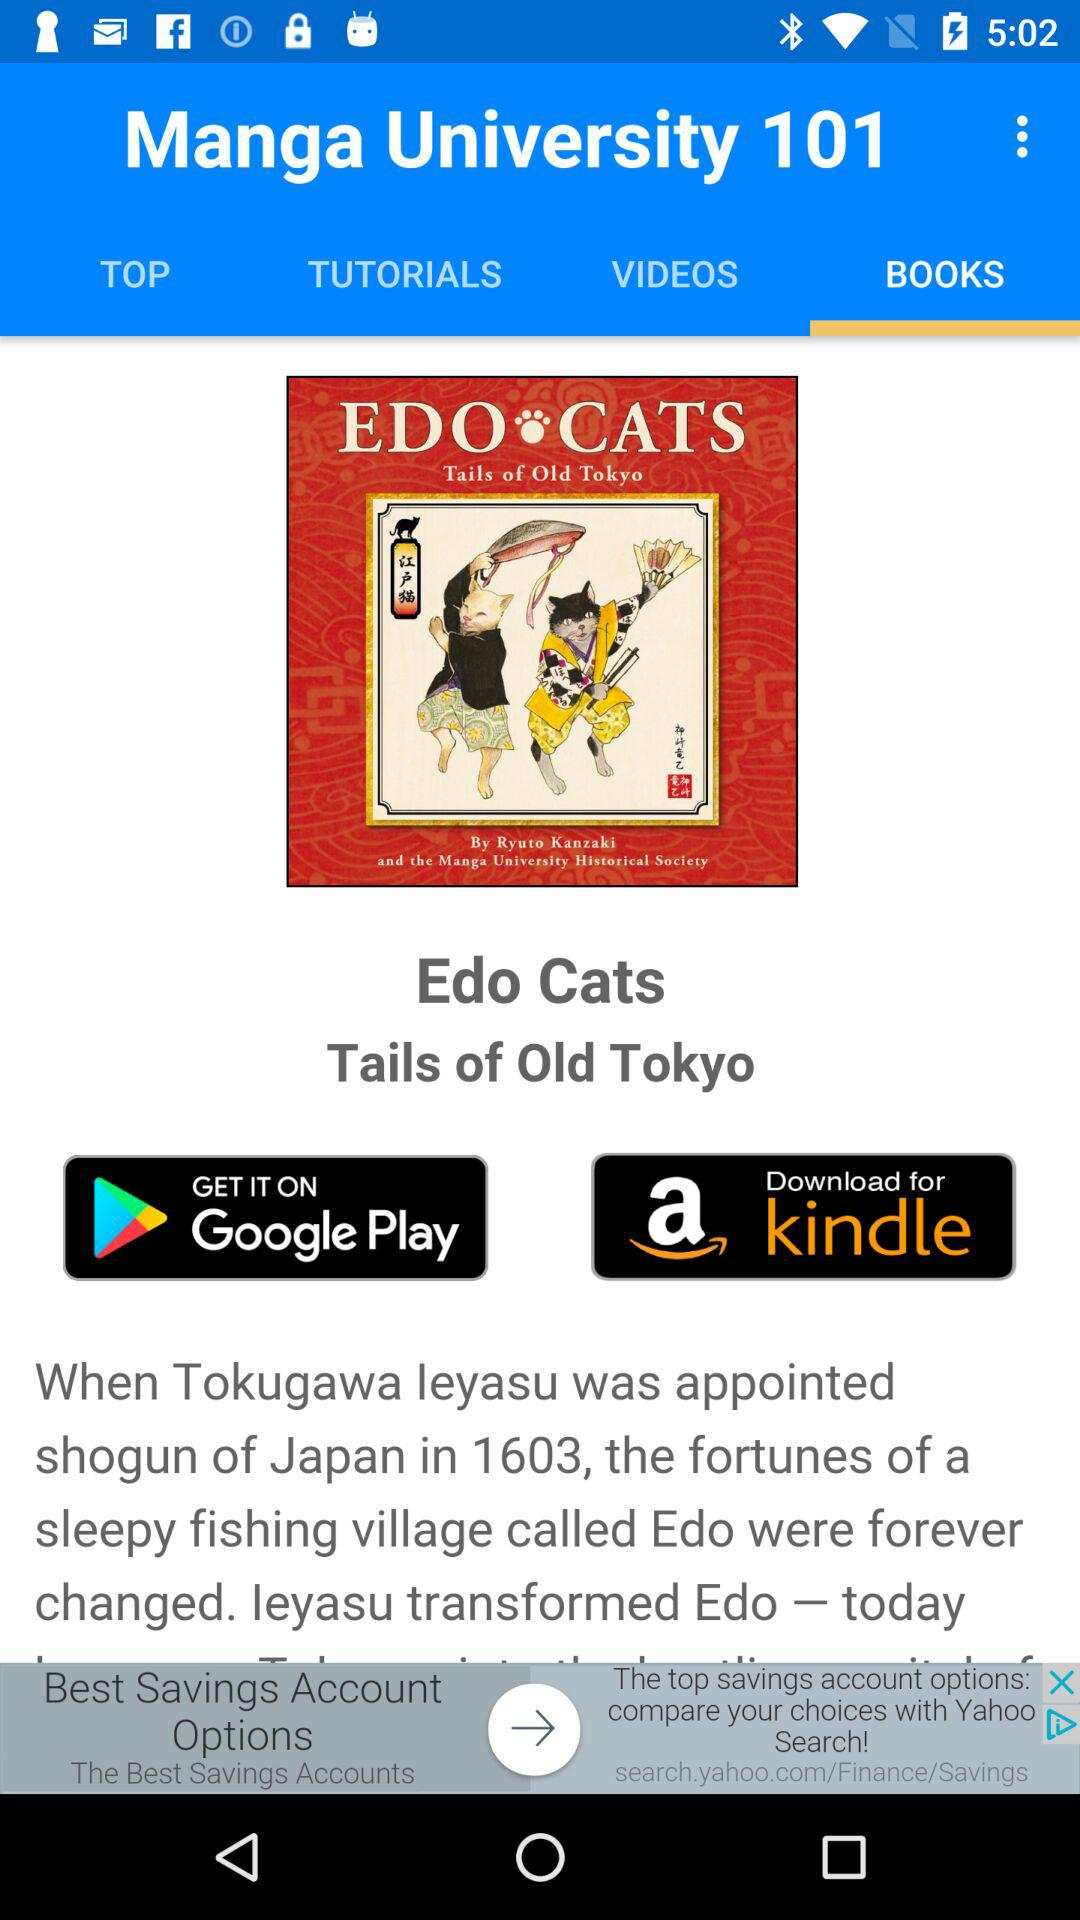What tab is selected? The selected tab is "BOOKS". 